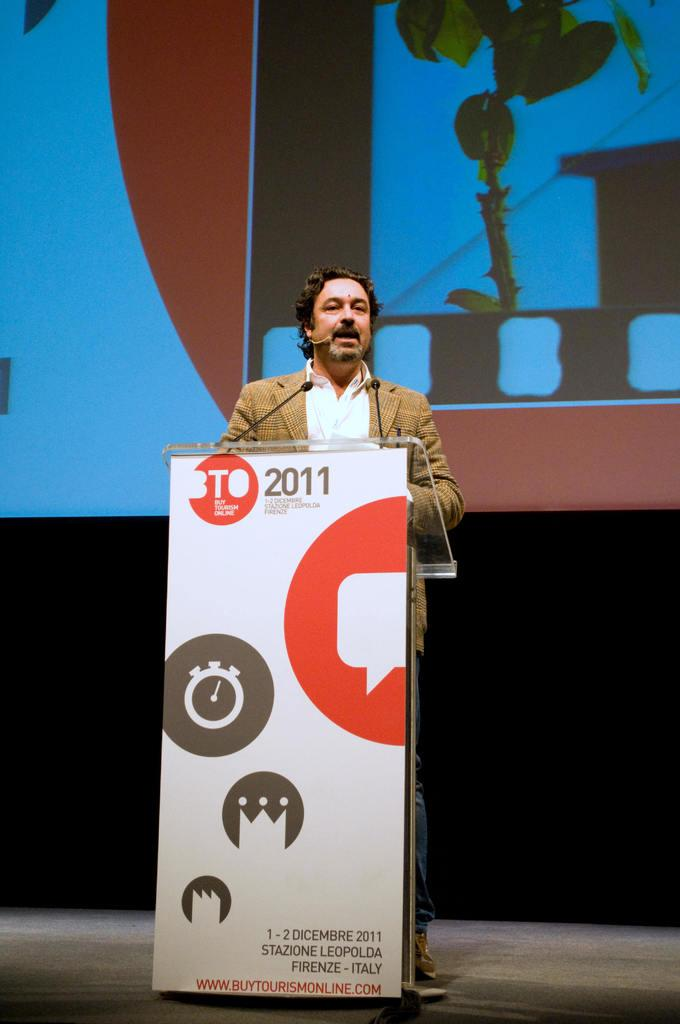<image>
Relay a brief, clear account of the picture shown. A man in a tan jacket at a podium with a BTO 2011 sign on it 